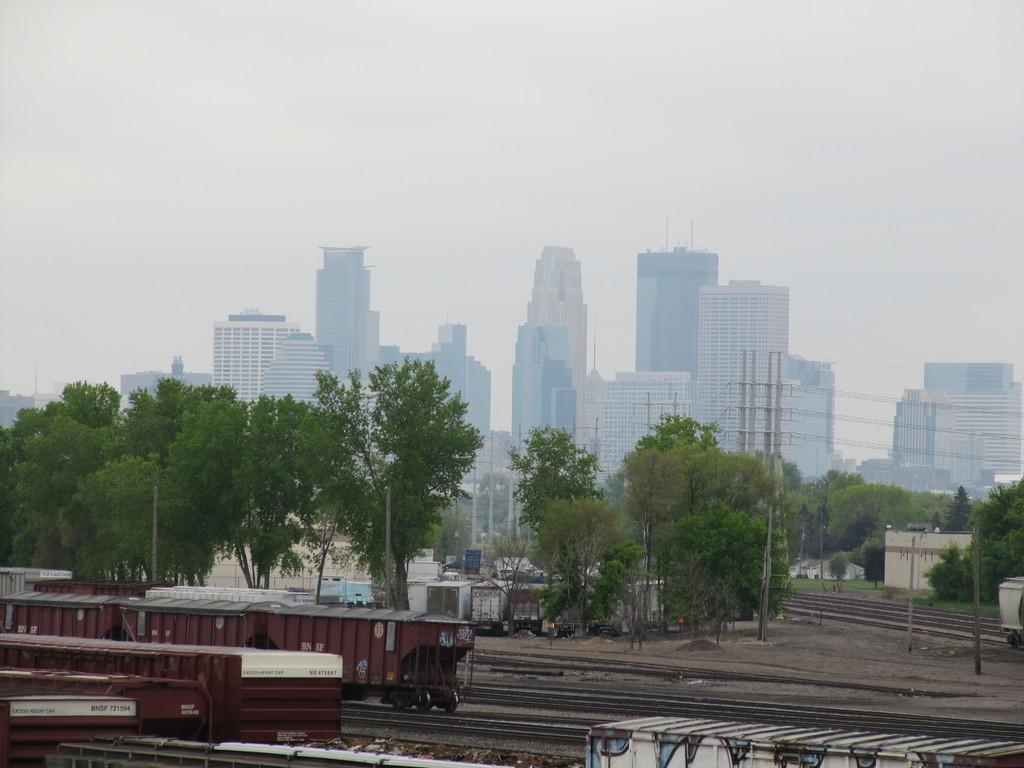Please provide a concise description of this image. In the image we can see there are many buildings, trees, poles and electric wires. Here we can see the trains on the tracks and the sky. 